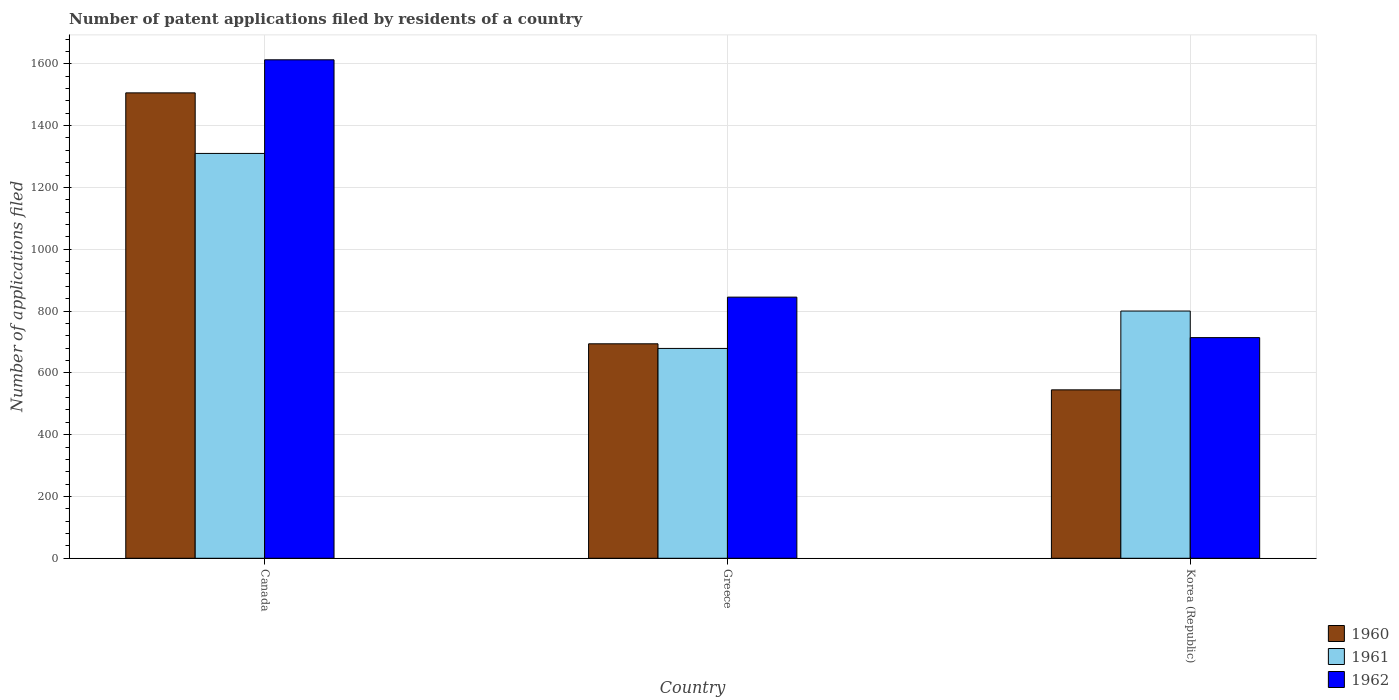Are the number of bars per tick equal to the number of legend labels?
Offer a terse response. Yes. How many bars are there on the 1st tick from the right?
Your answer should be compact. 3. What is the number of applications filed in 1961 in Canada?
Provide a succinct answer. 1310. Across all countries, what is the maximum number of applications filed in 1962?
Keep it short and to the point. 1613. Across all countries, what is the minimum number of applications filed in 1960?
Make the answer very short. 545. In which country was the number of applications filed in 1960 maximum?
Offer a very short reply. Canada. In which country was the number of applications filed in 1962 minimum?
Offer a very short reply. Korea (Republic). What is the total number of applications filed in 1961 in the graph?
Offer a terse response. 2789. What is the difference between the number of applications filed in 1962 in Greece and that in Korea (Republic)?
Offer a terse response. 131. What is the average number of applications filed in 1962 per country?
Offer a very short reply. 1057.33. What is the difference between the number of applications filed of/in 1960 and number of applications filed of/in 1961 in Korea (Republic)?
Provide a succinct answer. -255. What is the ratio of the number of applications filed in 1960 in Canada to that in Greece?
Make the answer very short. 2.17. Is the number of applications filed in 1962 in Canada less than that in Korea (Republic)?
Your answer should be very brief. No. Is the difference between the number of applications filed in 1960 in Greece and Korea (Republic) greater than the difference between the number of applications filed in 1961 in Greece and Korea (Republic)?
Keep it short and to the point. Yes. What is the difference between the highest and the second highest number of applications filed in 1961?
Provide a succinct answer. -510. What is the difference between the highest and the lowest number of applications filed in 1961?
Provide a succinct answer. 631. In how many countries, is the number of applications filed in 1962 greater than the average number of applications filed in 1962 taken over all countries?
Give a very brief answer. 1. Is it the case that in every country, the sum of the number of applications filed in 1960 and number of applications filed in 1961 is greater than the number of applications filed in 1962?
Provide a succinct answer. Yes. Are all the bars in the graph horizontal?
Keep it short and to the point. No. Does the graph contain grids?
Offer a very short reply. Yes. How are the legend labels stacked?
Keep it short and to the point. Vertical. What is the title of the graph?
Ensure brevity in your answer.  Number of patent applications filed by residents of a country. Does "1967" appear as one of the legend labels in the graph?
Provide a succinct answer. No. What is the label or title of the X-axis?
Make the answer very short. Country. What is the label or title of the Y-axis?
Offer a terse response. Number of applications filed. What is the Number of applications filed of 1960 in Canada?
Give a very brief answer. 1506. What is the Number of applications filed in 1961 in Canada?
Provide a succinct answer. 1310. What is the Number of applications filed of 1962 in Canada?
Provide a succinct answer. 1613. What is the Number of applications filed of 1960 in Greece?
Offer a terse response. 694. What is the Number of applications filed of 1961 in Greece?
Make the answer very short. 679. What is the Number of applications filed of 1962 in Greece?
Offer a terse response. 845. What is the Number of applications filed in 1960 in Korea (Republic)?
Offer a very short reply. 545. What is the Number of applications filed in 1961 in Korea (Republic)?
Ensure brevity in your answer.  800. What is the Number of applications filed of 1962 in Korea (Republic)?
Your answer should be very brief. 714. Across all countries, what is the maximum Number of applications filed in 1960?
Keep it short and to the point. 1506. Across all countries, what is the maximum Number of applications filed in 1961?
Your answer should be very brief. 1310. Across all countries, what is the maximum Number of applications filed in 1962?
Give a very brief answer. 1613. Across all countries, what is the minimum Number of applications filed of 1960?
Make the answer very short. 545. Across all countries, what is the minimum Number of applications filed of 1961?
Provide a succinct answer. 679. Across all countries, what is the minimum Number of applications filed in 1962?
Keep it short and to the point. 714. What is the total Number of applications filed in 1960 in the graph?
Give a very brief answer. 2745. What is the total Number of applications filed of 1961 in the graph?
Provide a succinct answer. 2789. What is the total Number of applications filed in 1962 in the graph?
Provide a short and direct response. 3172. What is the difference between the Number of applications filed of 1960 in Canada and that in Greece?
Give a very brief answer. 812. What is the difference between the Number of applications filed of 1961 in Canada and that in Greece?
Offer a very short reply. 631. What is the difference between the Number of applications filed of 1962 in Canada and that in Greece?
Ensure brevity in your answer.  768. What is the difference between the Number of applications filed of 1960 in Canada and that in Korea (Republic)?
Provide a short and direct response. 961. What is the difference between the Number of applications filed in 1961 in Canada and that in Korea (Republic)?
Offer a very short reply. 510. What is the difference between the Number of applications filed of 1962 in Canada and that in Korea (Republic)?
Provide a short and direct response. 899. What is the difference between the Number of applications filed of 1960 in Greece and that in Korea (Republic)?
Offer a terse response. 149. What is the difference between the Number of applications filed of 1961 in Greece and that in Korea (Republic)?
Ensure brevity in your answer.  -121. What is the difference between the Number of applications filed in 1962 in Greece and that in Korea (Republic)?
Provide a succinct answer. 131. What is the difference between the Number of applications filed of 1960 in Canada and the Number of applications filed of 1961 in Greece?
Your response must be concise. 827. What is the difference between the Number of applications filed of 1960 in Canada and the Number of applications filed of 1962 in Greece?
Your answer should be very brief. 661. What is the difference between the Number of applications filed of 1961 in Canada and the Number of applications filed of 1962 in Greece?
Provide a succinct answer. 465. What is the difference between the Number of applications filed of 1960 in Canada and the Number of applications filed of 1961 in Korea (Republic)?
Your response must be concise. 706. What is the difference between the Number of applications filed of 1960 in Canada and the Number of applications filed of 1962 in Korea (Republic)?
Provide a short and direct response. 792. What is the difference between the Number of applications filed in 1961 in Canada and the Number of applications filed in 1962 in Korea (Republic)?
Keep it short and to the point. 596. What is the difference between the Number of applications filed in 1960 in Greece and the Number of applications filed in 1961 in Korea (Republic)?
Provide a short and direct response. -106. What is the difference between the Number of applications filed of 1960 in Greece and the Number of applications filed of 1962 in Korea (Republic)?
Ensure brevity in your answer.  -20. What is the difference between the Number of applications filed in 1961 in Greece and the Number of applications filed in 1962 in Korea (Republic)?
Provide a short and direct response. -35. What is the average Number of applications filed in 1960 per country?
Provide a short and direct response. 915. What is the average Number of applications filed in 1961 per country?
Provide a short and direct response. 929.67. What is the average Number of applications filed in 1962 per country?
Make the answer very short. 1057.33. What is the difference between the Number of applications filed of 1960 and Number of applications filed of 1961 in Canada?
Your response must be concise. 196. What is the difference between the Number of applications filed of 1960 and Number of applications filed of 1962 in Canada?
Your answer should be very brief. -107. What is the difference between the Number of applications filed of 1961 and Number of applications filed of 1962 in Canada?
Give a very brief answer. -303. What is the difference between the Number of applications filed of 1960 and Number of applications filed of 1962 in Greece?
Ensure brevity in your answer.  -151. What is the difference between the Number of applications filed in 1961 and Number of applications filed in 1962 in Greece?
Offer a terse response. -166. What is the difference between the Number of applications filed in 1960 and Number of applications filed in 1961 in Korea (Republic)?
Give a very brief answer. -255. What is the difference between the Number of applications filed in 1960 and Number of applications filed in 1962 in Korea (Republic)?
Keep it short and to the point. -169. What is the ratio of the Number of applications filed of 1960 in Canada to that in Greece?
Ensure brevity in your answer.  2.17. What is the ratio of the Number of applications filed of 1961 in Canada to that in Greece?
Your response must be concise. 1.93. What is the ratio of the Number of applications filed of 1962 in Canada to that in Greece?
Provide a succinct answer. 1.91. What is the ratio of the Number of applications filed in 1960 in Canada to that in Korea (Republic)?
Provide a short and direct response. 2.76. What is the ratio of the Number of applications filed in 1961 in Canada to that in Korea (Republic)?
Keep it short and to the point. 1.64. What is the ratio of the Number of applications filed in 1962 in Canada to that in Korea (Republic)?
Your answer should be very brief. 2.26. What is the ratio of the Number of applications filed in 1960 in Greece to that in Korea (Republic)?
Keep it short and to the point. 1.27. What is the ratio of the Number of applications filed of 1961 in Greece to that in Korea (Republic)?
Provide a short and direct response. 0.85. What is the ratio of the Number of applications filed of 1962 in Greece to that in Korea (Republic)?
Give a very brief answer. 1.18. What is the difference between the highest and the second highest Number of applications filed of 1960?
Keep it short and to the point. 812. What is the difference between the highest and the second highest Number of applications filed of 1961?
Give a very brief answer. 510. What is the difference between the highest and the second highest Number of applications filed in 1962?
Your response must be concise. 768. What is the difference between the highest and the lowest Number of applications filed in 1960?
Offer a terse response. 961. What is the difference between the highest and the lowest Number of applications filed of 1961?
Provide a succinct answer. 631. What is the difference between the highest and the lowest Number of applications filed of 1962?
Provide a succinct answer. 899. 